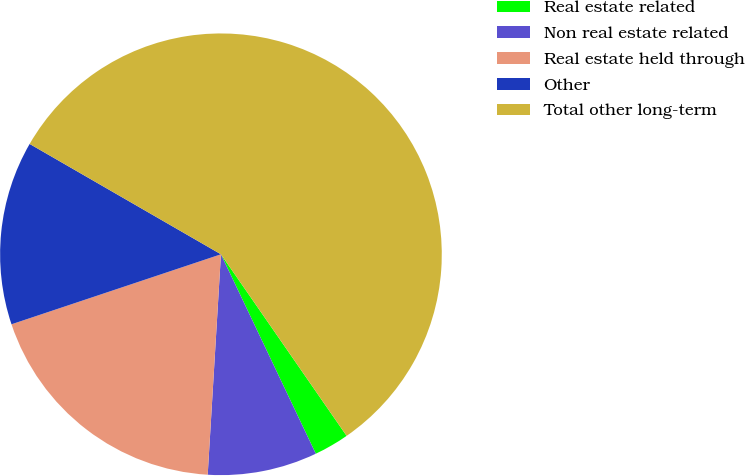Convert chart. <chart><loc_0><loc_0><loc_500><loc_500><pie_chart><fcel>Real estate related<fcel>Non real estate related<fcel>Real estate held through<fcel>Other<fcel>Total other long-term<nl><fcel>2.57%<fcel>8.02%<fcel>18.91%<fcel>13.46%<fcel>57.03%<nl></chart> 